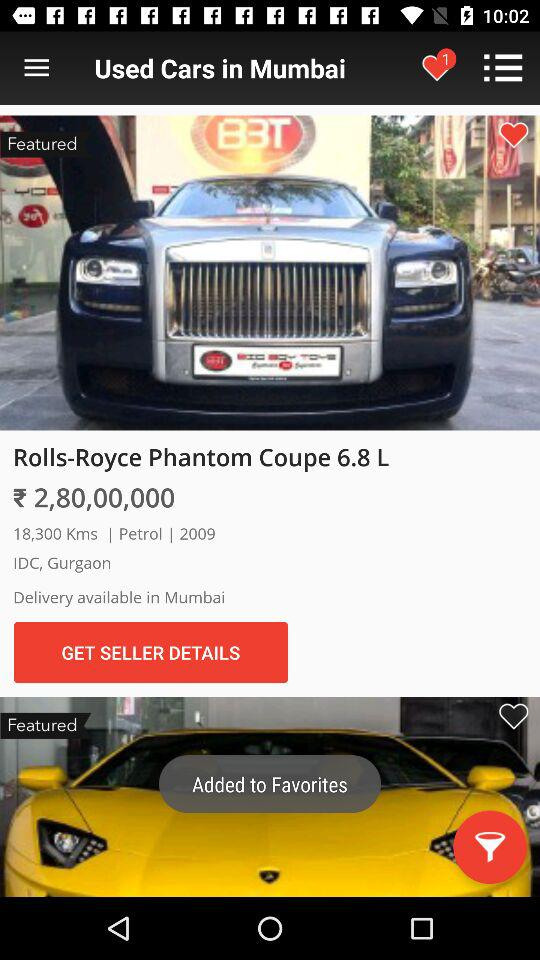What is the number of favorites? The number of favorites is 1. 